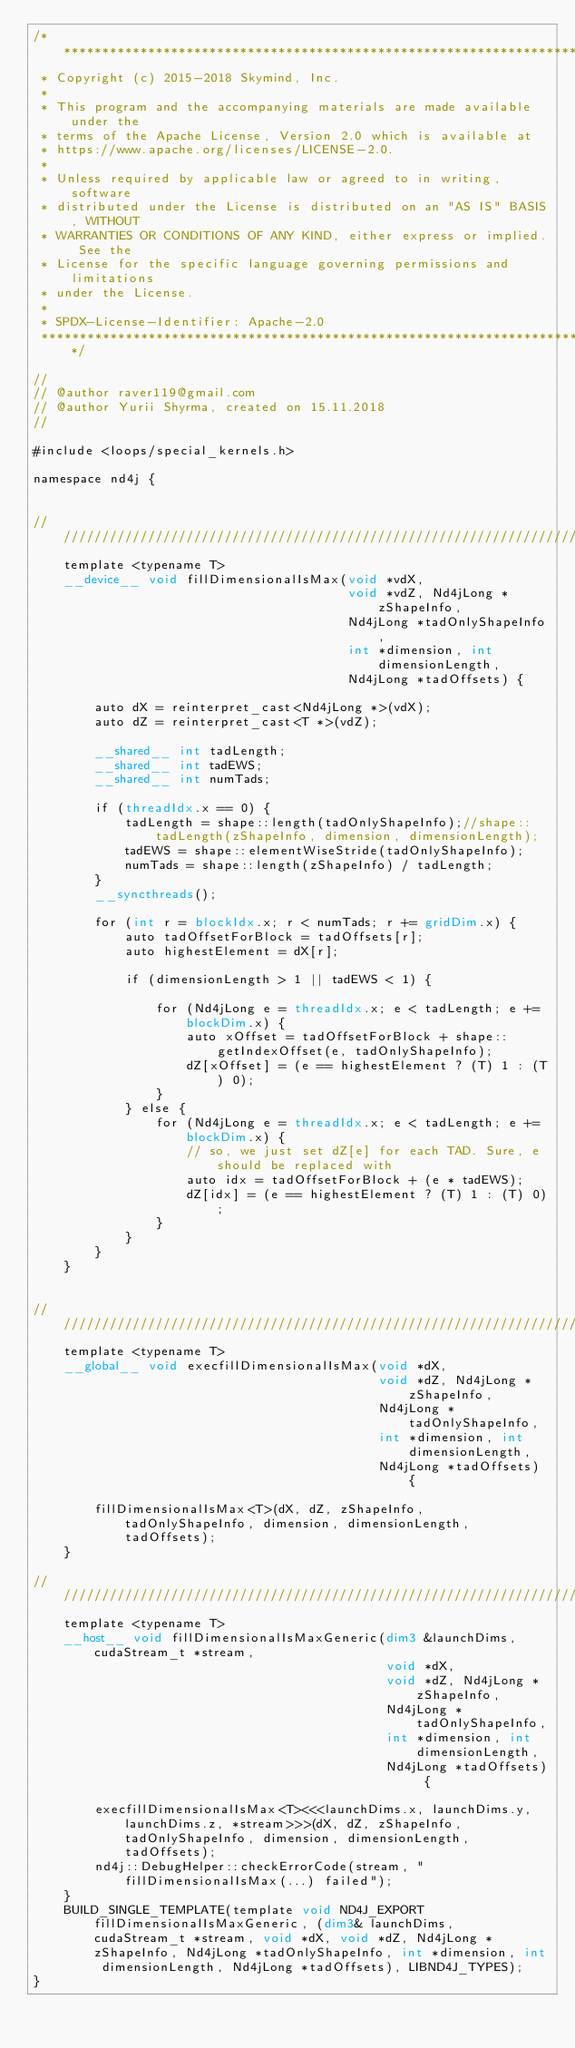<code> <loc_0><loc_0><loc_500><loc_500><_Cuda_>/*******************************************************************************
 * Copyright (c) 2015-2018 Skymind, Inc.
 *
 * This program and the accompanying materials are made available under the
 * terms of the Apache License, Version 2.0 which is available at
 * https://www.apache.org/licenses/LICENSE-2.0.
 *
 * Unless required by applicable law or agreed to in writing, software
 * distributed under the License is distributed on an "AS IS" BASIS, WITHOUT
 * WARRANTIES OR CONDITIONS OF ANY KIND, either express or implied. See the
 * License for the specific language governing permissions and limitations
 * under the License.
 *
 * SPDX-License-Identifier: Apache-2.0
 ******************************************************************************/

//
// @author raver119@gmail.com
// @author Yurii Shyrma, created on 15.11.2018
//

#include <loops/special_kernels.h>

namespace nd4j {


////////////////////////////////////////////////////////////////////////
    template <typename T>
    __device__ void fillDimensionalIsMax(void *vdX,
                                         void *vdZ, Nd4jLong *zShapeInfo,
                                         Nd4jLong *tadOnlyShapeInfo,
                                         int *dimension, int dimensionLength,
                                         Nd4jLong *tadOffsets) {

        auto dX = reinterpret_cast<Nd4jLong *>(vdX);
        auto dZ = reinterpret_cast<T *>(vdZ);

        __shared__ int tadLength;
        __shared__ int tadEWS;
        __shared__ int numTads;

        if (threadIdx.x == 0) {
            tadLength = shape::length(tadOnlyShapeInfo);//shape::tadLength(zShapeInfo, dimension, dimensionLength);
            tadEWS = shape::elementWiseStride(tadOnlyShapeInfo);
            numTads = shape::length(zShapeInfo) / tadLength;
        }
        __syncthreads();

        for (int r = blockIdx.x; r < numTads; r += gridDim.x) {
            auto tadOffsetForBlock = tadOffsets[r];
            auto highestElement = dX[r];

            if (dimensionLength > 1 || tadEWS < 1) {

                for (Nd4jLong e = threadIdx.x; e < tadLength; e += blockDim.x) {
                    auto xOffset = tadOffsetForBlock + shape::getIndexOffset(e, tadOnlyShapeInfo);
                    dZ[xOffset] = (e == highestElement ? (T) 1 : (T) 0);
                }
            } else {
                for (Nd4jLong e = threadIdx.x; e < tadLength; e += blockDim.x) {
                    // so, we just set dZ[e] for each TAD. Sure, e should be replaced with
                    auto idx = tadOffsetForBlock + (e * tadEWS);
                    dZ[idx] = (e == highestElement ? (T) 1 : (T) 0);
                }
            }
        }
    }


////////////////////////////////////////////////////////////////////////
    template <typename T>
    __global__ void execfillDimensionalIsMax(void *dX,
                                             void *dZ, Nd4jLong *zShapeInfo,
                                             Nd4jLong *tadOnlyShapeInfo,
                                             int *dimension, int dimensionLength,
                                             Nd4jLong *tadOffsets) {

        fillDimensionalIsMax<T>(dX, dZ, zShapeInfo, tadOnlyShapeInfo, dimension, dimensionLength, tadOffsets);
    }

////////////////////////////////////////////////////////////////////////
    template <typename T>
    __host__ void fillDimensionalIsMaxGeneric(dim3 &launchDims, cudaStream_t *stream,
                                              void *dX,
                                              void *dZ, Nd4jLong *zShapeInfo,
                                              Nd4jLong *tadOnlyShapeInfo,
                                              int *dimension, int dimensionLength,
                                              Nd4jLong *tadOffsets) {

        execfillDimensionalIsMax<T><<<launchDims.x, launchDims.y, launchDims.z, *stream>>>(dX, dZ, zShapeInfo, tadOnlyShapeInfo, dimension, dimensionLength, tadOffsets);
        nd4j::DebugHelper::checkErrorCode(stream, "fillDimensionalIsMax(...) failed");
    }
    BUILD_SINGLE_TEMPLATE(template void ND4J_EXPORT fillDimensionalIsMaxGeneric, (dim3& launchDims, cudaStream_t *stream, void *dX, void *dZ, Nd4jLong *zShapeInfo, Nd4jLong *tadOnlyShapeInfo, int *dimension, int dimensionLength, Nd4jLong *tadOffsets), LIBND4J_TYPES);
}</code> 